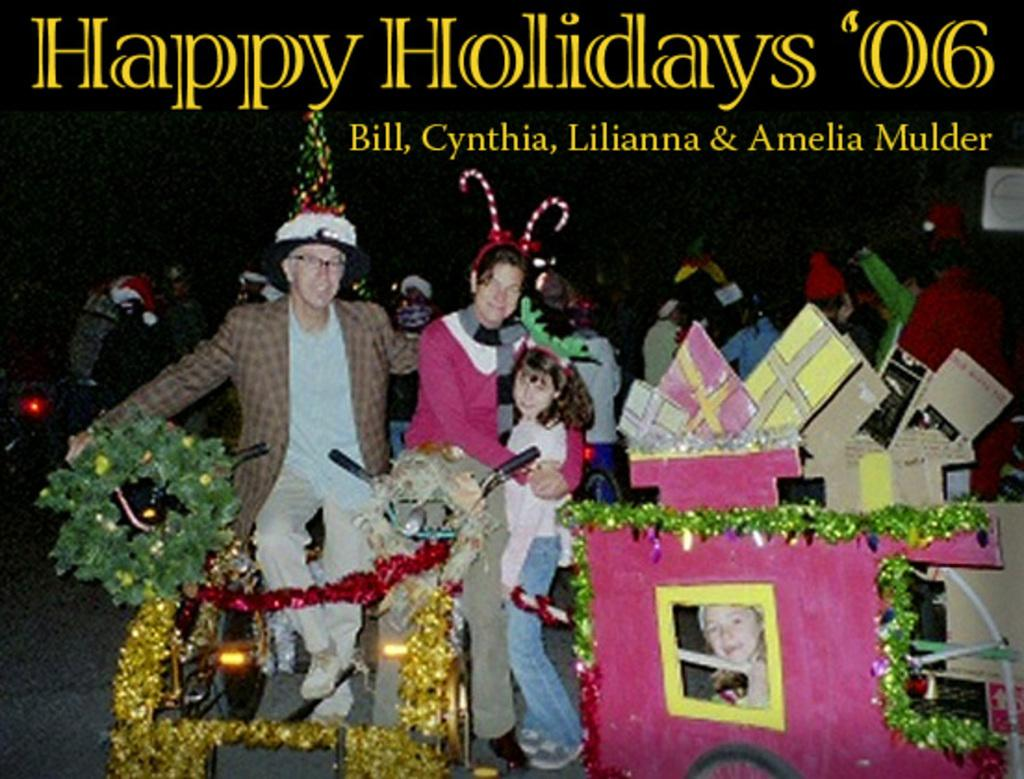Who or what is present in the image? There are people in the image. What can be seen on the right side of the image? There are colorful objects on the right side of the image. What is written at the top of the image? There is written text at the top of the image. Can you hear the sound of thunder in the image? There is no sound or thunder present in the image; it is a visual representation. 